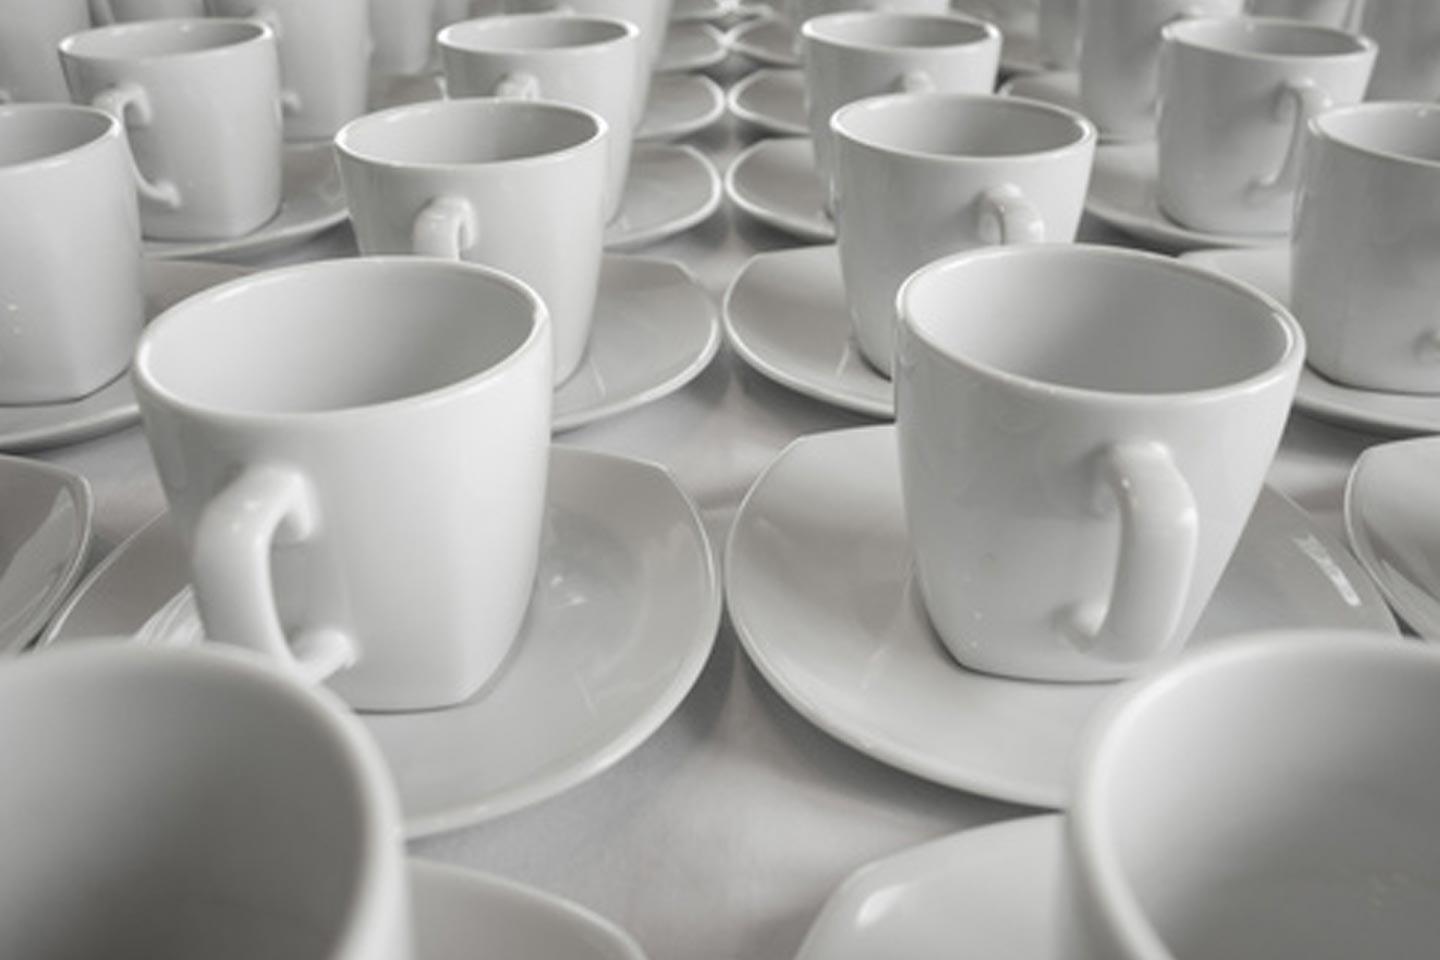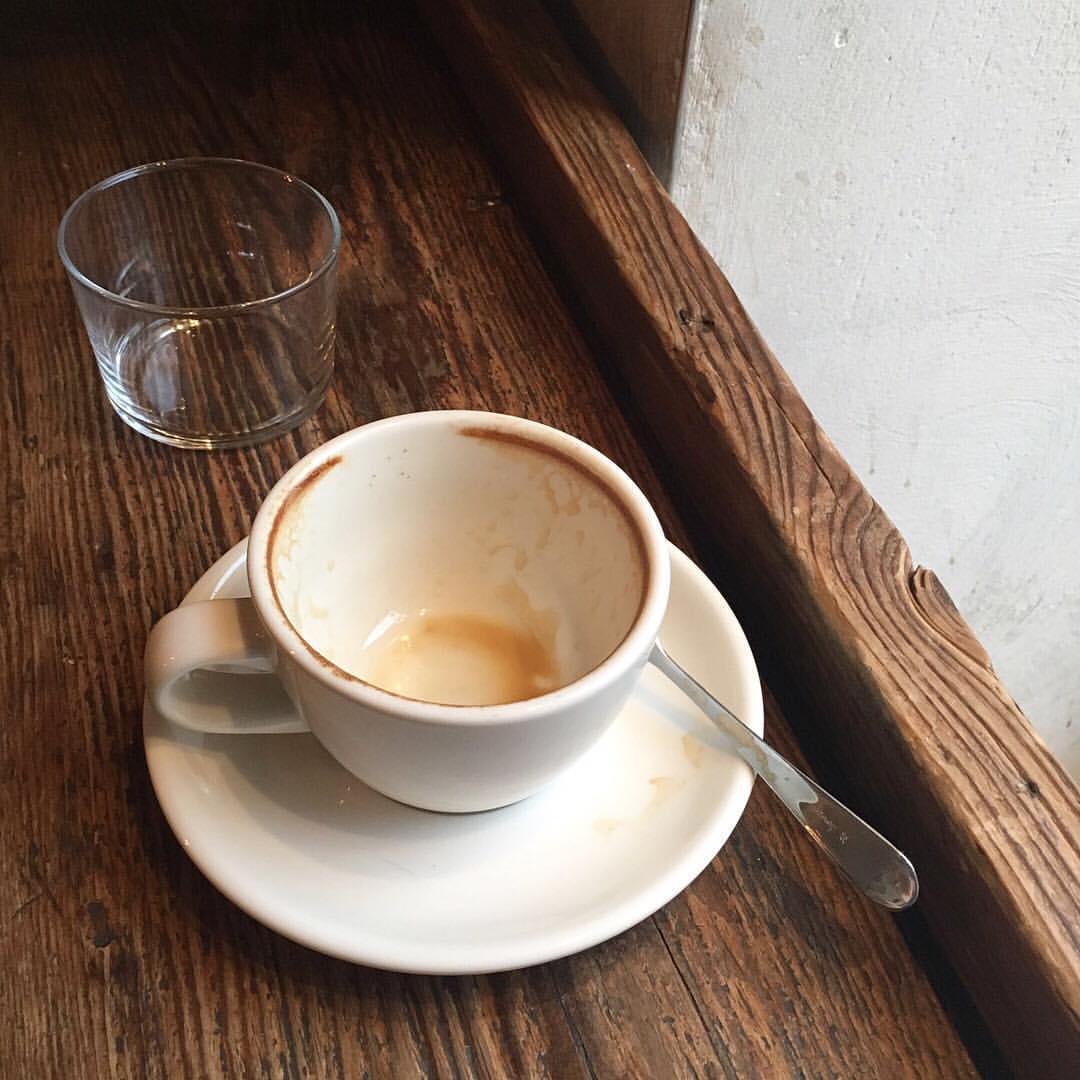The first image is the image on the left, the second image is the image on the right. For the images shown, is this caption "In at least one image there is a dirty coffee cup with a spoon set on the cup plate." true? Answer yes or no. Yes. The first image is the image on the left, the second image is the image on the right. Analyze the images presented: Is the assertion "A single dirty coffee cup sits on a table." valid? Answer yes or no. Yes. 